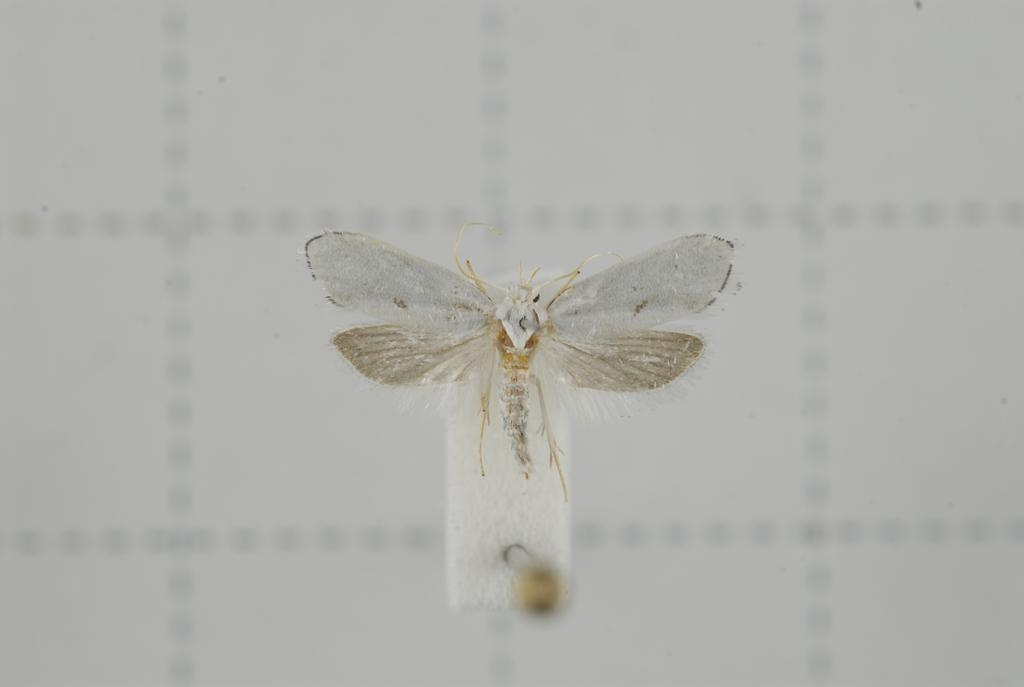What is the main subject of the image? There is an insect in the middle of the image. What color is the background of the image? The background of the image is white. How many fish are swimming in the yarn in the image? There are no fish or yarn present in the image; it features an insect with a white background. 